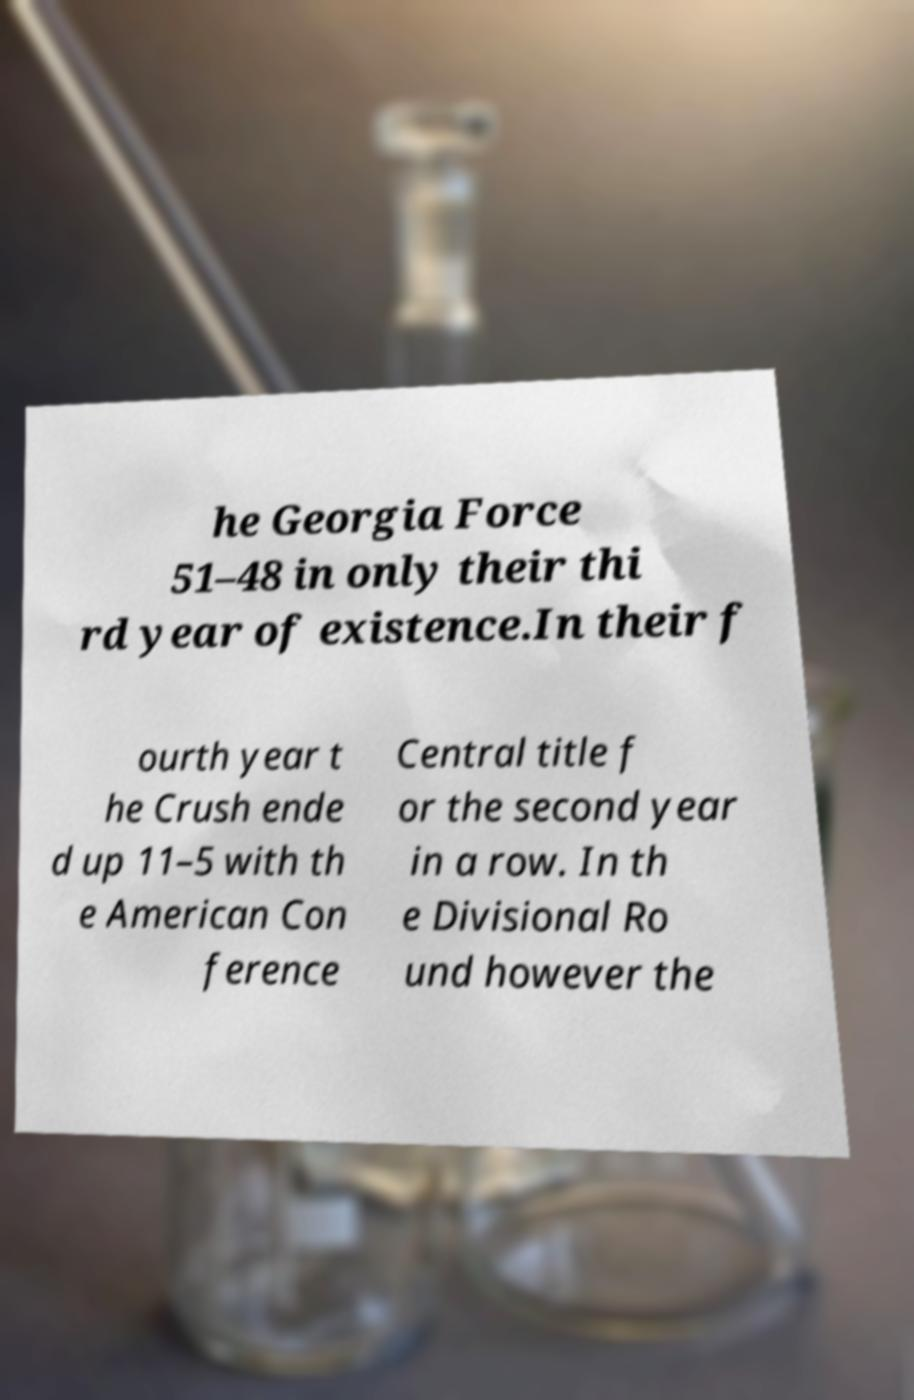Please read and relay the text visible in this image. What does it say? he Georgia Force 51–48 in only their thi rd year of existence.In their f ourth year t he Crush ende d up 11–5 with th e American Con ference Central title f or the second year in a row. In th e Divisional Ro und however the 